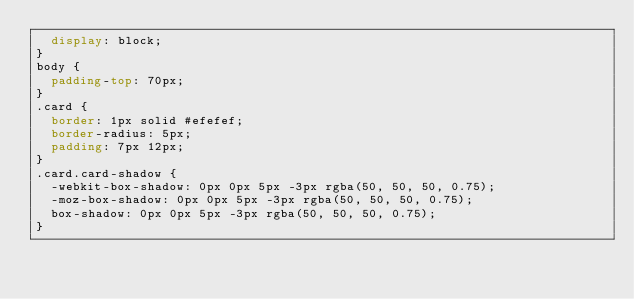Convert code to text. <code><loc_0><loc_0><loc_500><loc_500><_CSS_>  display: block;
}
body {
  padding-top: 70px;
}
.card {
  border: 1px solid #efefef;
  border-radius: 5px;
  padding: 7px 12px;
}
.card.card-shadow {
  -webkit-box-shadow: 0px 0px 5px -3px rgba(50, 50, 50, 0.75);
  -moz-box-shadow: 0px 0px 5px -3px rgba(50, 50, 50, 0.75);
  box-shadow: 0px 0px 5px -3px rgba(50, 50, 50, 0.75);
}
</code> 